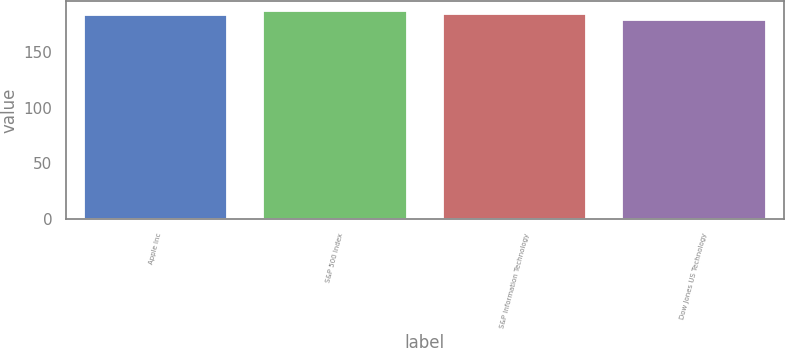Convert chart to OTSL. <chart><loc_0><loc_0><loc_500><loc_500><bar_chart><fcel>Apple Inc<fcel>S&P 500 Index<fcel>S&P Information Technology<fcel>Dow Jones US Technology<nl><fcel>183<fcel>186<fcel>183.8<fcel>178<nl></chart> 